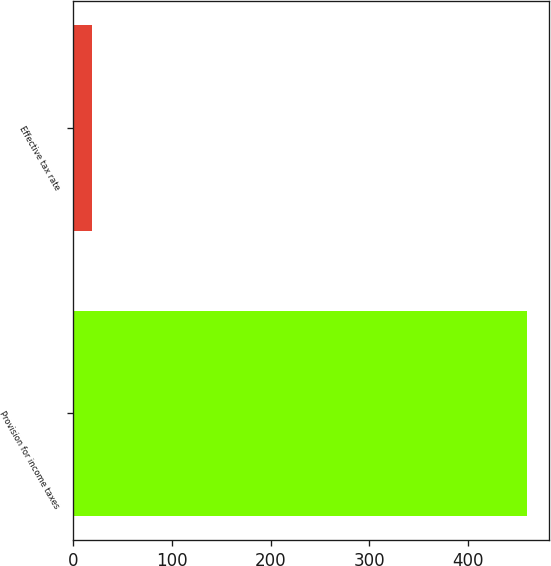<chart> <loc_0><loc_0><loc_500><loc_500><bar_chart><fcel>Provision for income taxes<fcel>Effective tax rate<nl><fcel>459<fcel>19<nl></chart> 